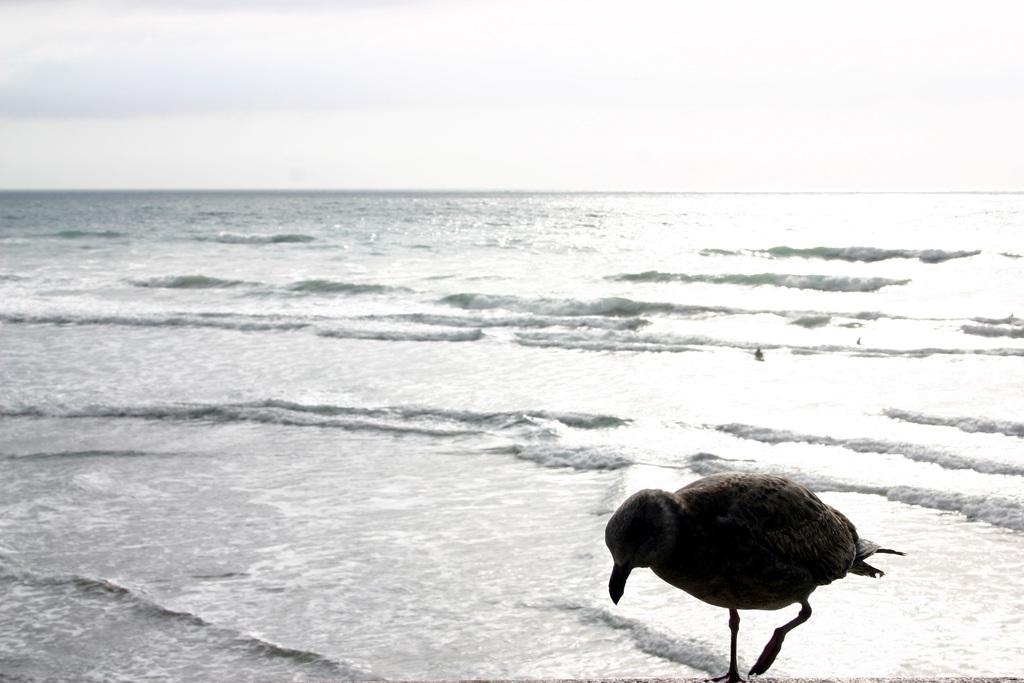What is the main subject of the image? There is a bird standing in the image. What can be seen in the background of the image? There are tides of an ocean in the background of the image. What is visible in the sky in the image? There are clouds in the sky in the image. What type of behavior does the bird exhibit towards the thrill in the image? There is no thrill present in the image, as the facts only mention the bird, ocean tides, and clouds in the sky. 